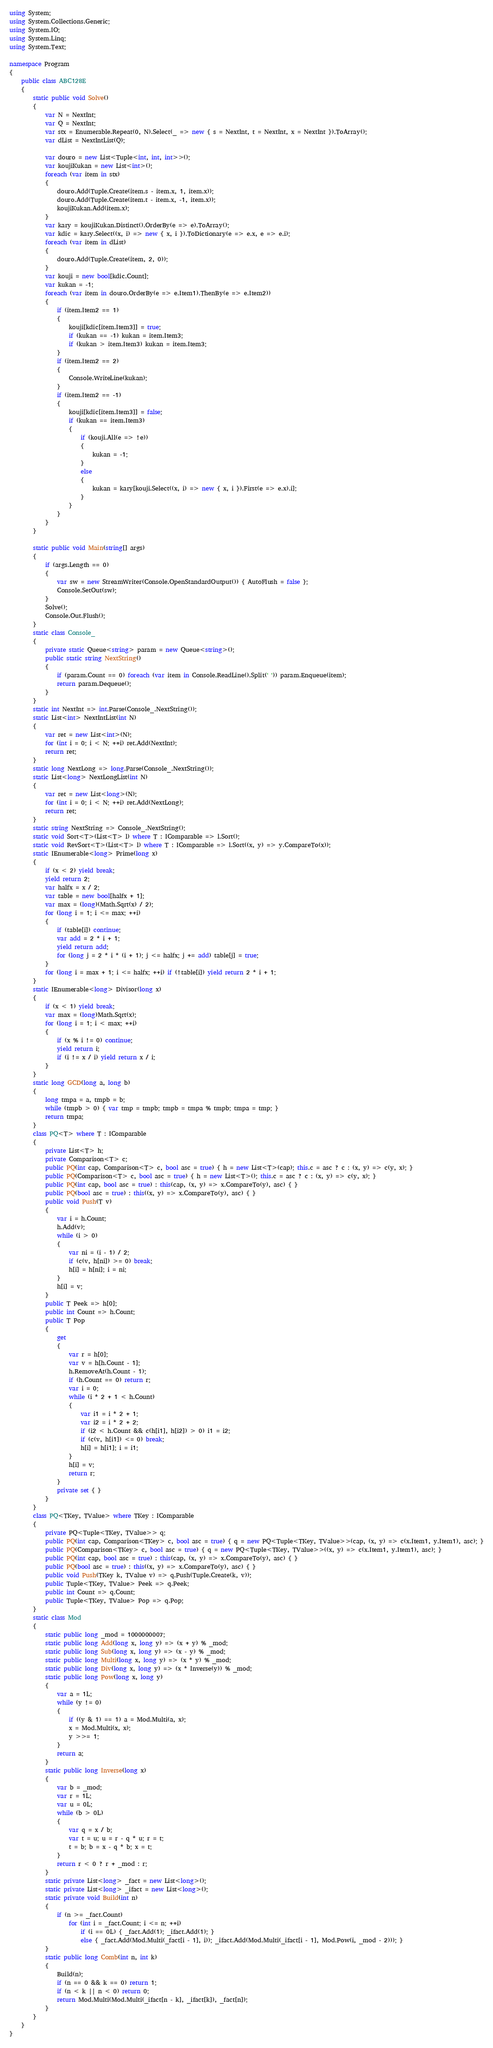<code> <loc_0><loc_0><loc_500><loc_500><_C#_>using System;
using System.Collections.Generic;
using System.IO;
using System.Linq;
using System.Text;

namespace Program
{
    public class ABC128E
    {
        static public void Solve()
        {
            var N = NextInt;
            var Q = NextInt;
            var stx = Enumerable.Repeat(0, N).Select(_ => new { s = NextInt, t = NextInt, x = NextInt }).ToArray();
            var dList = NextIntList(Q);

            var douro = new List<Tuple<int, int, int>>();
            var koujiKukan = new List<int>();
            foreach (var item in stx)
            {
                douro.Add(Tuple.Create(item.s - item.x, 1, item.x));
                douro.Add(Tuple.Create(item.t - item.x, -1, item.x));
                koujiKukan.Add(item.x);
            }
            var kary = koujiKukan.Distinct().OrderBy(e => e).ToArray();
            var kdic = kary.Select((x, i) => new { x, i }).ToDictionary(e => e.x, e => e.i);
            foreach (var item in dList)
            {
                douro.Add(Tuple.Create(item, 2, 0));
            }
            var kouji = new bool[kdic.Count];
            var kukan = -1;
            foreach (var item in douro.OrderBy(e => e.Item1).ThenBy(e => e.Item2))
            {
                if (item.Item2 == 1)
                {
                    kouji[kdic[item.Item3]] = true;
                    if (kukan == -1) kukan = item.Item3;
                    if (kukan > item.Item3) kukan = item.Item3;
                }
                if (item.Item2 == 2)
                {
                    Console.WriteLine(kukan);
                }
                if (item.Item2 == -1)
                {
                    kouji[kdic[item.Item3]] = false;
                    if (kukan == item.Item3)
                    {
                        if (kouji.All(e => !e))
                        {
                            kukan = -1;
                        }
                        else
                        {
                            kukan = kary[kouji.Select((x, i) => new { x, i }).First(e => e.x).i];
                        }
                    }
                }
            }
        }

        static public void Main(string[] args)
        {
            if (args.Length == 0)
            {
                var sw = new StreamWriter(Console.OpenStandardOutput()) { AutoFlush = false };
                Console.SetOut(sw);
            }
            Solve();
            Console.Out.Flush();
        }
        static class Console_
        {
            private static Queue<string> param = new Queue<string>();
            public static string NextString()
            {
                if (param.Count == 0) foreach (var item in Console.ReadLine().Split(' ')) param.Enqueue(item);
                return param.Dequeue();
            }
        }
        static int NextInt => int.Parse(Console_.NextString());
        static List<int> NextIntList(int N)
        {
            var ret = new List<int>(N);
            for (int i = 0; i < N; ++i) ret.Add(NextInt);
            return ret;
        }
        static long NextLong => long.Parse(Console_.NextString());
        static List<long> NextLongList(int N)
        {
            var ret = new List<long>(N);
            for (int i = 0; i < N; ++i) ret.Add(NextLong);
            return ret;
        }
        static string NextString => Console_.NextString();
        static void Sort<T>(List<T> l) where T : IComparable => l.Sort();
        static void RevSort<T>(List<T> l) where T : IComparable => l.Sort((x, y) => y.CompareTo(x));
        static IEnumerable<long> Prime(long x)
        {
            if (x < 2) yield break;
            yield return 2;
            var halfx = x / 2;
            var table = new bool[halfx + 1];
            var max = (long)(Math.Sqrt(x) / 2);
            for (long i = 1; i <= max; ++i)
            {
                if (table[i]) continue;
                var add = 2 * i + 1;
                yield return add;
                for (long j = 2 * i * (i + 1); j <= halfx; j += add) table[j] = true;
            }
            for (long i = max + 1; i <= halfx; ++i) if (!table[i]) yield return 2 * i + 1;
        }
        static IEnumerable<long> Divisor(long x)
        {
            if (x < 1) yield break;
            var max = (long)Math.Sqrt(x);
            for (long i = 1; i < max; ++i)
            {
                if (x % i != 0) continue;
                yield return i;
                if (i != x / i) yield return x / i;
            }
        }
        static long GCD(long a, long b)
        {
            long tmpa = a, tmpb = b;
            while (tmpb > 0) { var tmp = tmpb; tmpb = tmpa % tmpb; tmpa = tmp; }
            return tmpa;
        }
        class PQ<T> where T : IComparable
        {
            private List<T> h;
            private Comparison<T> c;
            public PQ(int cap, Comparison<T> c, bool asc = true) { h = new List<T>(cap); this.c = asc ? c : (x, y) => c(y, x); }
            public PQ(Comparison<T> c, bool asc = true) { h = new List<T>(); this.c = asc ? c : (x, y) => c(y, x); }
            public PQ(int cap, bool asc = true) : this(cap, (x, y) => x.CompareTo(y), asc) { }
            public PQ(bool asc = true) : this((x, y) => x.CompareTo(y), asc) { }
            public void Push(T v)
            {
                var i = h.Count;
                h.Add(v);
                while (i > 0)
                {
                    var ni = (i - 1) / 2;
                    if (c(v, h[ni]) >= 0) break;
                    h[i] = h[ni]; i = ni;
                }
                h[i] = v;
            }
            public T Peek => h[0];
            public int Count => h.Count;
            public T Pop
            {
                get
                {
                    var r = h[0];
                    var v = h[h.Count - 1];
                    h.RemoveAt(h.Count - 1);
                    if (h.Count == 0) return r;
                    var i = 0;
                    while (i * 2 + 1 < h.Count)
                    {
                        var i1 = i * 2 + 1;
                        var i2 = i * 2 + 2;
                        if (i2 < h.Count && c(h[i1], h[i2]) > 0) i1 = i2;
                        if (c(v, h[i1]) <= 0) break;
                        h[i] = h[i1]; i = i1;
                    }
                    h[i] = v;
                    return r;
                }
                private set { }
            }
        }
        class PQ<TKey, TValue> where TKey : IComparable
        {
            private PQ<Tuple<TKey, TValue>> q;
            public PQ(int cap, Comparison<TKey> c, bool asc = true) { q = new PQ<Tuple<TKey, TValue>>(cap, (x, y) => c(x.Item1, y.Item1), asc); }
            public PQ(Comparison<TKey> c, bool asc = true) { q = new PQ<Tuple<TKey, TValue>>((x, y) => c(x.Item1, y.Item1), asc); }
            public PQ(int cap, bool asc = true) : this(cap, (x, y) => x.CompareTo(y), asc) { }
            public PQ(bool asc = true) : this((x, y) => x.CompareTo(y), asc) { }
            public void Push(TKey k, TValue v) => q.Push(Tuple.Create(k, v));
            public Tuple<TKey, TValue> Peek => q.Peek;
            public int Count => q.Count;
            public Tuple<TKey, TValue> Pop => q.Pop;
        }
        static class Mod
        {
            static public long _mod = 1000000007;
            static public long Add(long x, long y) => (x + y) % _mod;
            static public long Sub(long x, long y) => (x - y) % _mod;
            static public long Multi(long x, long y) => (x * y) % _mod;
            static public long Div(long x, long y) => (x * Inverse(y)) % _mod;
            static public long Pow(long x, long y)
            {
                var a = 1L;
                while (y != 0)
                {
                    if ((y & 1) == 1) a = Mod.Multi(a, x);
                    x = Mod.Multi(x, x);
                    y >>= 1;
                }
                return a;
            }
            static public long Inverse(long x)
            {
                var b = _mod;
                var r = 1L;
                var u = 0L;
                while (b > 0L)
                {
                    var q = x / b;
                    var t = u; u = r - q * u; r = t;
                    t = b; b = x - q * b; x = t;
                }
                return r < 0 ? r + _mod : r;
            }
            static private List<long> _fact = new List<long>();
            static private List<long> _ifact = new List<long>();
            static private void Build(int n)
            {
                if (n >= _fact.Count)
                    for (int i = _fact.Count; i <= n; ++i)
                        if (i == 0L) { _fact.Add(1); _ifact.Add(1); }
                        else { _fact.Add(Mod.Multi(_fact[i - 1], i)); _ifact.Add(Mod.Multi(_ifact[i - 1], Mod.Pow(i, _mod - 2))); }
            }
            static public long Comb(int n, int k)
            {
                Build(n);
                if (n == 0 && k == 0) return 1;
                if (n < k || n < 0) return 0;
                return Mod.Multi(Mod.Multi(_ifact[n - k], _ifact[k]), _fact[n]);
            }
        }
    }
}
</code> 